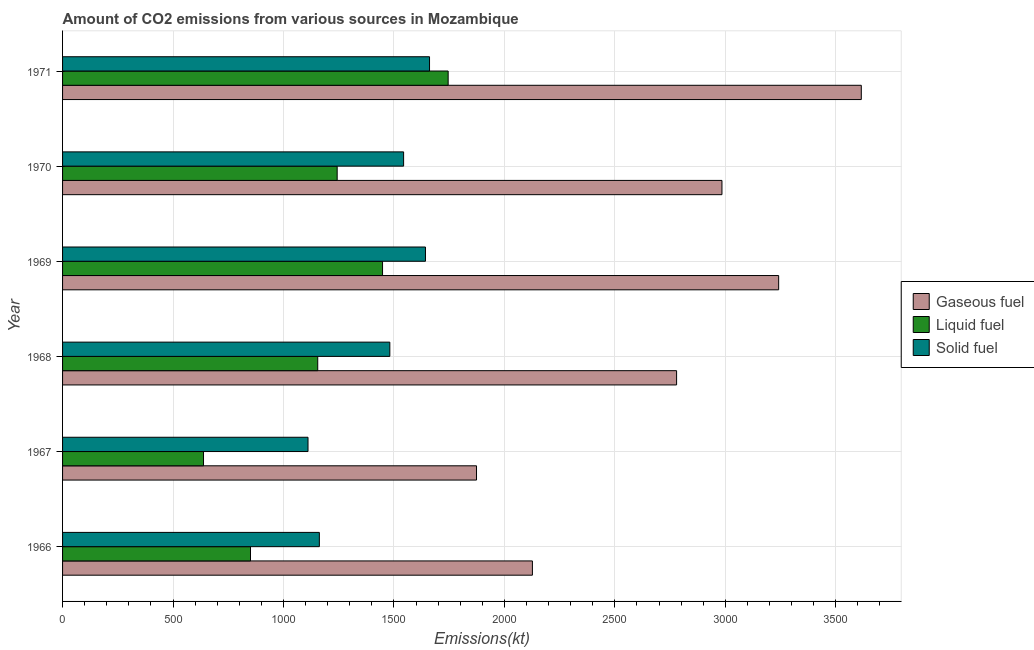How many different coloured bars are there?
Ensure brevity in your answer.  3. How many groups of bars are there?
Provide a succinct answer. 6. How many bars are there on the 5th tick from the top?
Your response must be concise. 3. How many bars are there on the 2nd tick from the bottom?
Your answer should be very brief. 3. What is the label of the 2nd group of bars from the top?
Make the answer very short. 1970. What is the amount of co2 emissions from solid fuel in 1966?
Offer a terse response. 1162.44. Across all years, what is the maximum amount of co2 emissions from gaseous fuel?
Give a very brief answer. 3615.66. Across all years, what is the minimum amount of co2 emissions from solid fuel?
Offer a very short reply. 1111.1. In which year was the amount of co2 emissions from liquid fuel maximum?
Provide a succinct answer. 1971. In which year was the amount of co2 emissions from liquid fuel minimum?
Make the answer very short. 1967. What is the total amount of co2 emissions from liquid fuel in the graph?
Make the answer very short. 7080.98. What is the difference between the amount of co2 emissions from liquid fuel in 1967 and that in 1971?
Offer a terse response. -1107.43. What is the difference between the amount of co2 emissions from liquid fuel in 1968 and the amount of co2 emissions from solid fuel in 1971?
Your answer should be very brief. -506.05. What is the average amount of co2 emissions from solid fuel per year?
Provide a succinct answer. 1433.8. In the year 1967, what is the difference between the amount of co2 emissions from solid fuel and amount of co2 emissions from liquid fuel?
Provide a short and direct response. 473.04. In how many years, is the amount of co2 emissions from liquid fuel greater than 200 kt?
Offer a very short reply. 6. What is the ratio of the amount of co2 emissions from gaseous fuel in 1969 to that in 1971?
Offer a terse response. 0.9. What is the difference between the highest and the second highest amount of co2 emissions from liquid fuel?
Your response must be concise. 297.03. What is the difference between the highest and the lowest amount of co2 emissions from gaseous fuel?
Your answer should be very brief. 1741.82. What does the 3rd bar from the top in 1966 represents?
Keep it short and to the point. Gaseous fuel. What does the 2nd bar from the bottom in 1971 represents?
Your answer should be very brief. Liquid fuel. Are all the bars in the graph horizontal?
Keep it short and to the point. Yes. What is the difference between two consecutive major ticks on the X-axis?
Provide a succinct answer. 500. Are the values on the major ticks of X-axis written in scientific E-notation?
Provide a succinct answer. No. Does the graph contain any zero values?
Your answer should be very brief. No. Does the graph contain grids?
Offer a very short reply. Yes. What is the title of the graph?
Give a very brief answer. Amount of CO2 emissions from various sources in Mozambique. Does "Total employers" appear as one of the legend labels in the graph?
Your answer should be very brief. No. What is the label or title of the X-axis?
Your answer should be very brief. Emissions(kt). What is the Emissions(kt) of Gaseous fuel in 1966?
Provide a succinct answer. 2126.86. What is the Emissions(kt) in Liquid fuel in 1966?
Provide a short and direct response. 850.74. What is the Emissions(kt) in Solid fuel in 1966?
Keep it short and to the point. 1162.44. What is the Emissions(kt) in Gaseous fuel in 1967?
Your response must be concise. 1873.84. What is the Emissions(kt) of Liquid fuel in 1967?
Offer a very short reply. 638.06. What is the Emissions(kt) in Solid fuel in 1967?
Ensure brevity in your answer.  1111.1. What is the Emissions(kt) in Gaseous fuel in 1968?
Your answer should be compact. 2779.59. What is the Emissions(kt) of Liquid fuel in 1968?
Your answer should be very brief. 1155.11. What is the Emissions(kt) of Solid fuel in 1968?
Provide a short and direct response. 1481.47. What is the Emissions(kt) in Gaseous fuel in 1969?
Your answer should be very brief. 3241.63. What is the Emissions(kt) of Liquid fuel in 1969?
Your answer should be very brief. 1448.46. What is the Emissions(kt) of Solid fuel in 1969?
Give a very brief answer. 1642.82. What is the Emissions(kt) of Gaseous fuel in 1970?
Give a very brief answer. 2984.94. What is the Emissions(kt) in Liquid fuel in 1970?
Your response must be concise. 1243.11. What is the Emissions(kt) of Solid fuel in 1970?
Ensure brevity in your answer.  1543.81. What is the Emissions(kt) in Gaseous fuel in 1971?
Your answer should be very brief. 3615.66. What is the Emissions(kt) of Liquid fuel in 1971?
Provide a short and direct response. 1745.49. What is the Emissions(kt) of Solid fuel in 1971?
Provide a short and direct response. 1661.15. Across all years, what is the maximum Emissions(kt) of Gaseous fuel?
Provide a short and direct response. 3615.66. Across all years, what is the maximum Emissions(kt) in Liquid fuel?
Give a very brief answer. 1745.49. Across all years, what is the maximum Emissions(kt) of Solid fuel?
Give a very brief answer. 1661.15. Across all years, what is the minimum Emissions(kt) of Gaseous fuel?
Your answer should be very brief. 1873.84. Across all years, what is the minimum Emissions(kt) of Liquid fuel?
Your answer should be very brief. 638.06. Across all years, what is the minimum Emissions(kt) in Solid fuel?
Make the answer very short. 1111.1. What is the total Emissions(kt) of Gaseous fuel in the graph?
Your answer should be very brief. 1.66e+04. What is the total Emissions(kt) in Liquid fuel in the graph?
Offer a very short reply. 7080.98. What is the total Emissions(kt) in Solid fuel in the graph?
Offer a terse response. 8602.78. What is the difference between the Emissions(kt) in Gaseous fuel in 1966 and that in 1967?
Ensure brevity in your answer.  253.02. What is the difference between the Emissions(kt) in Liquid fuel in 1966 and that in 1967?
Provide a short and direct response. 212.69. What is the difference between the Emissions(kt) of Solid fuel in 1966 and that in 1967?
Your answer should be very brief. 51.34. What is the difference between the Emissions(kt) in Gaseous fuel in 1966 and that in 1968?
Your answer should be compact. -652.73. What is the difference between the Emissions(kt) in Liquid fuel in 1966 and that in 1968?
Offer a terse response. -304.36. What is the difference between the Emissions(kt) in Solid fuel in 1966 and that in 1968?
Make the answer very short. -319.03. What is the difference between the Emissions(kt) of Gaseous fuel in 1966 and that in 1969?
Ensure brevity in your answer.  -1114.77. What is the difference between the Emissions(kt) of Liquid fuel in 1966 and that in 1969?
Your response must be concise. -597.72. What is the difference between the Emissions(kt) in Solid fuel in 1966 and that in 1969?
Your answer should be very brief. -480.38. What is the difference between the Emissions(kt) of Gaseous fuel in 1966 and that in 1970?
Give a very brief answer. -858.08. What is the difference between the Emissions(kt) in Liquid fuel in 1966 and that in 1970?
Make the answer very short. -392.37. What is the difference between the Emissions(kt) of Solid fuel in 1966 and that in 1970?
Give a very brief answer. -381.37. What is the difference between the Emissions(kt) in Gaseous fuel in 1966 and that in 1971?
Your response must be concise. -1488.8. What is the difference between the Emissions(kt) in Liquid fuel in 1966 and that in 1971?
Provide a short and direct response. -894.75. What is the difference between the Emissions(kt) in Solid fuel in 1966 and that in 1971?
Make the answer very short. -498.71. What is the difference between the Emissions(kt) of Gaseous fuel in 1967 and that in 1968?
Ensure brevity in your answer.  -905.75. What is the difference between the Emissions(kt) of Liquid fuel in 1967 and that in 1968?
Offer a terse response. -517.05. What is the difference between the Emissions(kt) of Solid fuel in 1967 and that in 1968?
Offer a very short reply. -370.37. What is the difference between the Emissions(kt) in Gaseous fuel in 1967 and that in 1969?
Your answer should be very brief. -1367.79. What is the difference between the Emissions(kt) in Liquid fuel in 1967 and that in 1969?
Make the answer very short. -810.41. What is the difference between the Emissions(kt) of Solid fuel in 1967 and that in 1969?
Keep it short and to the point. -531.72. What is the difference between the Emissions(kt) of Gaseous fuel in 1967 and that in 1970?
Make the answer very short. -1111.1. What is the difference between the Emissions(kt) in Liquid fuel in 1967 and that in 1970?
Offer a terse response. -605.05. What is the difference between the Emissions(kt) of Solid fuel in 1967 and that in 1970?
Your answer should be very brief. -432.71. What is the difference between the Emissions(kt) in Gaseous fuel in 1967 and that in 1971?
Provide a short and direct response. -1741.83. What is the difference between the Emissions(kt) of Liquid fuel in 1967 and that in 1971?
Give a very brief answer. -1107.43. What is the difference between the Emissions(kt) in Solid fuel in 1967 and that in 1971?
Ensure brevity in your answer.  -550.05. What is the difference between the Emissions(kt) in Gaseous fuel in 1968 and that in 1969?
Your response must be concise. -462.04. What is the difference between the Emissions(kt) in Liquid fuel in 1968 and that in 1969?
Your response must be concise. -293.36. What is the difference between the Emissions(kt) of Solid fuel in 1968 and that in 1969?
Your answer should be very brief. -161.35. What is the difference between the Emissions(kt) in Gaseous fuel in 1968 and that in 1970?
Provide a succinct answer. -205.35. What is the difference between the Emissions(kt) of Liquid fuel in 1968 and that in 1970?
Your answer should be compact. -88.01. What is the difference between the Emissions(kt) of Solid fuel in 1968 and that in 1970?
Keep it short and to the point. -62.34. What is the difference between the Emissions(kt) in Gaseous fuel in 1968 and that in 1971?
Provide a short and direct response. -836.08. What is the difference between the Emissions(kt) of Liquid fuel in 1968 and that in 1971?
Ensure brevity in your answer.  -590.39. What is the difference between the Emissions(kt) of Solid fuel in 1968 and that in 1971?
Offer a very short reply. -179.68. What is the difference between the Emissions(kt) of Gaseous fuel in 1969 and that in 1970?
Your response must be concise. 256.69. What is the difference between the Emissions(kt) in Liquid fuel in 1969 and that in 1970?
Your response must be concise. 205.35. What is the difference between the Emissions(kt) of Solid fuel in 1969 and that in 1970?
Your answer should be compact. 99.01. What is the difference between the Emissions(kt) in Gaseous fuel in 1969 and that in 1971?
Provide a short and direct response. -374.03. What is the difference between the Emissions(kt) in Liquid fuel in 1969 and that in 1971?
Ensure brevity in your answer.  -297.03. What is the difference between the Emissions(kt) of Solid fuel in 1969 and that in 1971?
Give a very brief answer. -18.34. What is the difference between the Emissions(kt) of Gaseous fuel in 1970 and that in 1971?
Offer a terse response. -630.72. What is the difference between the Emissions(kt) of Liquid fuel in 1970 and that in 1971?
Your answer should be very brief. -502.38. What is the difference between the Emissions(kt) in Solid fuel in 1970 and that in 1971?
Give a very brief answer. -117.34. What is the difference between the Emissions(kt) in Gaseous fuel in 1966 and the Emissions(kt) in Liquid fuel in 1967?
Offer a terse response. 1488.8. What is the difference between the Emissions(kt) of Gaseous fuel in 1966 and the Emissions(kt) of Solid fuel in 1967?
Your answer should be compact. 1015.76. What is the difference between the Emissions(kt) in Liquid fuel in 1966 and the Emissions(kt) in Solid fuel in 1967?
Keep it short and to the point. -260.36. What is the difference between the Emissions(kt) in Gaseous fuel in 1966 and the Emissions(kt) in Liquid fuel in 1968?
Offer a terse response. 971.75. What is the difference between the Emissions(kt) of Gaseous fuel in 1966 and the Emissions(kt) of Solid fuel in 1968?
Provide a succinct answer. 645.39. What is the difference between the Emissions(kt) of Liquid fuel in 1966 and the Emissions(kt) of Solid fuel in 1968?
Offer a terse response. -630.72. What is the difference between the Emissions(kt) of Gaseous fuel in 1966 and the Emissions(kt) of Liquid fuel in 1969?
Ensure brevity in your answer.  678.39. What is the difference between the Emissions(kt) in Gaseous fuel in 1966 and the Emissions(kt) in Solid fuel in 1969?
Your answer should be very brief. 484.04. What is the difference between the Emissions(kt) of Liquid fuel in 1966 and the Emissions(kt) of Solid fuel in 1969?
Give a very brief answer. -792.07. What is the difference between the Emissions(kt) in Gaseous fuel in 1966 and the Emissions(kt) in Liquid fuel in 1970?
Provide a succinct answer. 883.75. What is the difference between the Emissions(kt) of Gaseous fuel in 1966 and the Emissions(kt) of Solid fuel in 1970?
Your answer should be very brief. 583.05. What is the difference between the Emissions(kt) of Liquid fuel in 1966 and the Emissions(kt) of Solid fuel in 1970?
Offer a terse response. -693.06. What is the difference between the Emissions(kt) of Gaseous fuel in 1966 and the Emissions(kt) of Liquid fuel in 1971?
Provide a short and direct response. 381.37. What is the difference between the Emissions(kt) in Gaseous fuel in 1966 and the Emissions(kt) in Solid fuel in 1971?
Offer a very short reply. 465.71. What is the difference between the Emissions(kt) in Liquid fuel in 1966 and the Emissions(kt) in Solid fuel in 1971?
Keep it short and to the point. -810.41. What is the difference between the Emissions(kt) of Gaseous fuel in 1967 and the Emissions(kt) of Liquid fuel in 1968?
Give a very brief answer. 718.73. What is the difference between the Emissions(kt) in Gaseous fuel in 1967 and the Emissions(kt) in Solid fuel in 1968?
Provide a short and direct response. 392.37. What is the difference between the Emissions(kt) of Liquid fuel in 1967 and the Emissions(kt) of Solid fuel in 1968?
Provide a short and direct response. -843.41. What is the difference between the Emissions(kt) of Gaseous fuel in 1967 and the Emissions(kt) of Liquid fuel in 1969?
Offer a terse response. 425.37. What is the difference between the Emissions(kt) in Gaseous fuel in 1967 and the Emissions(kt) in Solid fuel in 1969?
Ensure brevity in your answer.  231.02. What is the difference between the Emissions(kt) of Liquid fuel in 1967 and the Emissions(kt) of Solid fuel in 1969?
Provide a short and direct response. -1004.76. What is the difference between the Emissions(kt) of Gaseous fuel in 1967 and the Emissions(kt) of Liquid fuel in 1970?
Ensure brevity in your answer.  630.72. What is the difference between the Emissions(kt) of Gaseous fuel in 1967 and the Emissions(kt) of Solid fuel in 1970?
Make the answer very short. 330.03. What is the difference between the Emissions(kt) of Liquid fuel in 1967 and the Emissions(kt) of Solid fuel in 1970?
Your answer should be very brief. -905.75. What is the difference between the Emissions(kt) of Gaseous fuel in 1967 and the Emissions(kt) of Liquid fuel in 1971?
Keep it short and to the point. 128.34. What is the difference between the Emissions(kt) of Gaseous fuel in 1967 and the Emissions(kt) of Solid fuel in 1971?
Your response must be concise. 212.69. What is the difference between the Emissions(kt) of Liquid fuel in 1967 and the Emissions(kt) of Solid fuel in 1971?
Ensure brevity in your answer.  -1023.09. What is the difference between the Emissions(kt) of Gaseous fuel in 1968 and the Emissions(kt) of Liquid fuel in 1969?
Your answer should be very brief. 1331.12. What is the difference between the Emissions(kt) in Gaseous fuel in 1968 and the Emissions(kt) in Solid fuel in 1969?
Offer a very short reply. 1136.77. What is the difference between the Emissions(kt) in Liquid fuel in 1968 and the Emissions(kt) in Solid fuel in 1969?
Your answer should be compact. -487.71. What is the difference between the Emissions(kt) of Gaseous fuel in 1968 and the Emissions(kt) of Liquid fuel in 1970?
Your answer should be very brief. 1536.47. What is the difference between the Emissions(kt) of Gaseous fuel in 1968 and the Emissions(kt) of Solid fuel in 1970?
Offer a terse response. 1235.78. What is the difference between the Emissions(kt) in Liquid fuel in 1968 and the Emissions(kt) in Solid fuel in 1970?
Provide a succinct answer. -388.7. What is the difference between the Emissions(kt) in Gaseous fuel in 1968 and the Emissions(kt) in Liquid fuel in 1971?
Ensure brevity in your answer.  1034.09. What is the difference between the Emissions(kt) of Gaseous fuel in 1968 and the Emissions(kt) of Solid fuel in 1971?
Offer a terse response. 1118.43. What is the difference between the Emissions(kt) of Liquid fuel in 1968 and the Emissions(kt) of Solid fuel in 1971?
Offer a very short reply. -506.05. What is the difference between the Emissions(kt) in Gaseous fuel in 1969 and the Emissions(kt) in Liquid fuel in 1970?
Your answer should be very brief. 1998.52. What is the difference between the Emissions(kt) in Gaseous fuel in 1969 and the Emissions(kt) in Solid fuel in 1970?
Your answer should be compact. 1697.82. What is the difference between the Emissions(kt) of Liquid fuel in 1969 and the Emissions(kt) of Solid fuel in 1970?
Offer a terse response. -95.34. What is the difference between the Emissions(kt) in Gaseous fuel in 1969 and the Emissions(kt) in Liquid fuel in 1971?
Your response must be concise. 1496.14. What is the difference between the Emissions(kt) of Gaseous fuel in 1969 and the Emissions(kt) of Solid fuel in 1971?
Give a very brief answer. 1580.48. What is the difference between the Emissions(kt) of Liquid fuel in 1969 and the Emissions(kt) of Solid fuel in 1971?
Your answer should be very brief. -212.69. What is the difference between the Emissions(kt) of Gaseous fuel in 1970 and the Emissions(kt) of Liquid fuel in 1971?
Provide a succinct answer. 1239.45. What is the difference between the Emissions(kt) in Gaseous fuel in 1970 and the Emissions(kt) in Solid fuel in 1971?
Your answer should be compact. 1323.79. What is the difference between the Emissions(kt) of Liquid fuel in 1970 and the Emissions(kt) of Solid fuel in 1971?
Ensure brevity in your answer.  -418.04. What is the average Emissions(kt) of Gaseous fuel per year?
Ensure brevity in your answer.  2770.42. What is the average Emissions(kt) of Liquid fuel per year?
Offer a terse response. 1180.16. What is the average Emissions(kt) in Solid fuel per year?
Your answer should be compact. 1433.8. In the year 1966, what is the difference between the Emissions(kt) in Gaseous fuel and Emissions(kt) in Liquid fuel?
Provide a short and direct response. 1276.12. In the year 1966, what is the difference between the Emissions(kt) of Gaseous fuel and Emissions(kt) of Solid fuel?
Make the answer very short. 964.42. In the year 1966, what is the difference between the Emissions(kt) in Liquid fuel and Emissions(kt) in Solid fuel?
Your answer should be compact. -311.69. In the year 1967, what is the difference between the Emissions(kt) of Gaseous fuel and Emissions(kt) of Liquid fuel?
Your answer should be very brief. 1235.78. In the year 1967, what is the difference between the Emissions(kt) of Gaseous fuel and Emissions(kt) of Solid fuel?
Make the answer very short. 762.74. In the year 1967, what is the difference between the Emissions(kt) of Liquid fuel and Emissions(kt) of Solid fuel?
Provide a short and direct response. -473.04. In the year 1968, what is the difference between the Emissions(kt) of Gaseous fuel and Emissions(kt) of Liquid fuel?
Offer a terse response. 1624.48. In the year 1968, what is the difference between the Emissions(kt) in Gaseous fuel and Emissions(kt) in Solid fuel?
Offer a very short reply. 1298.12. In the year 1968, what is the difference between the Emissions(kt) of Liquid fuel and Emissions(kt) of Solid fuel?
Offer a very short reply. -326.36. In the year 1969, what is the difference between the Emissions(kt) in Gaseous fuel and Emissions(kt) in Liquid fuel?
Your response must be concise. 1793.16. In the year 1969, what is the difference between the Emissions(kt) in Gaseous fuel and Emissions(kt) in Solid fuel?
Offer a terse response. 1598.81. In the year 1969, what is the difference between the Emissions(kt) of Liquid fuel and Emissions(kt) of Solid fuel?
Provide a short and direct response. -194.35. In the year 1970, what is the difference between the Emissions(kt) of Gaseous fuel and Emissions(kt) of Liquid fuel?
Your response must be concise. 1741.83. In the year 1970, what is the difference between the Emissions(kt) in Gaseous fuel and Emissions(kt) in Solid fuel?
Your answer should be very brief. 1441.13. In the year 1970, what is the difference between the Emissions(kt) in Liquid fuel and Emissions(kt) in Solid fuel?
Give a very brief answer. -300.69. In the year 1971, what is the difference between the Emissions(kt) of Gaseous fuel and Emissions(kt) of Liquid fuel?
Give a very brief answer. 1870.17. In the year 1971, what is the difference between the Emissions(kt) in Gaseous fuel and Emissions(kt) in Solid fuel?
Provide a succinct answer. 1954.51. In the year 1971, what is the difference between the Emissions(kt) in Liquid fuel and Emissions(kt) in Solid fuel?
Ensure brevity in your answer.  84.34. What is the ratio of the Emissions(kt) of Gaseous fuel in 1966 to that in 1967?
Offer a very short reply. 1.14. What is the ratio of the Emissions(kt) of Liquid fuel in 1966 to that in 1967?
Offer a very short reply. 1.33. What is the ratio of the Emissions(kt) of Solid fuel in 1966 to that in 1967?
Ensure brevity in your answer.  1.05. What is the ratio of the Emissions(kt) in Gaseous fuel in 1966 to that in 1968?
Provide a succinct answer. 0.77. What is the ratio of the Emissions(kt) in Liquid fuel in 1966 to that in 1968?
Ensure brevity in your answer.  0.74. What is the ratio of the Emissions(kt) in Solid fuel in 1966 to that in 1968?
Provide a short and direct response. 0.78. What is the ratio of the Emissions(kt) of Gaseous fuel in 1966 to that in 1969?
Provide a short and direct response. 0.66. What is the ratio of the Emissions(kt) in Liquid fuel in 1966 to that in 1969?
Keep it short and to the point. 0.59. What is the ratio of the Emissions(kt) of Solid fuel in 1966 to that in 1969?
Provide a succinct answer. 0.71. What is the ratio of the Emissions(kt) of Gaseous fuel in 1966 to that in 1970?
Your answer should be very brief. 0.71. What is the ratio of the Emissions(kt) in Liquid fuel in 1966 to that in 1970?
Keep it short and to the point. 0.68. What is the ratio of the Emissions(kt) in Solid fuel in 1966 to that in 1970?
Keep it short and to the point. 0.75. What is the ratio of the Emissions(kt) in Gaseous fuel in 1966 to that in 1971?
Your response must be concise. 0.59. What is the ratio of the Emissions(kt) of Liquid fuel in 1966 to that in 1971?
Ensure brevity in your answer.  0.49. What is the ratio of the Emissions(kt) of Solid fuel in 1966 to that in 1971?
Offer a very short reply. 0.7. What is the ratio of the Emissions(kt) of Gaseous fuel in 1967 to that in 1968?
Provide a succinct answer. 0.67. What is the ratio of the Emissions(kt) of Liquid fuel in 1967 to that in 1968?
Your response must be concise. 0.55. What is the ratio of the Emissions(kt) in Solid fuel in 1967 to that in 1968?
Make the answer very short. 0.75. What is the ratio of the Emissions(kt) of Gaseous fuel in 1967 to that in 1969?
Your answer should be compact. 0.58. What is the ratio of the Emissions(kt) in Liquid fuel in 1967 to that in 1969?
Keep it short and to the point. 0.44. What is the ratio of the Emissions(kt) in Solid fuel in 1967 to that in 1969?
Provide a succinct answer. 0.68. What is the ratio of the Emissions(kt) in Gaseous fuel in 1967 to that in 1970?
Your answer should be very brief. 0.63. What is the ratio of the Emissions(kt) in Liquid fuel in 1967 to that in 1970?
Offer a terse response. 0.51. What is the ratio of the Emissions(kt) in Solid fuel in 1967 to that in 1970?
Offer a very short reply. 0.72. What is the ratio of the Emissions(kt) in Gaseous fuel in 1967 to that in 1971?
Ensure brevity in your answer.  0.52. What is the ratio of the Emissions(kt) in Liquid fuel in 1967 to that in 1971?
Provide a short and direct response. 0.37. What is the ratio of the Emissions(kt) of Solid fuel in 1967 to that in 1971?
Keep it short and to the point. 0.67. What is the ratio of the Emissions(kt) in Gaseous fuel in 1968 to that in 1969?
Your answer should be compact. 0.86. What is the ratio of the Emissions(kt) of Liquid fuel in 1968 to that in 1969?
Give a very brief answer. 0.8. What is the ratio of the Emissions(kt) of Solid fuel in 1968 to that in 1969?
Ensure brevity in your answer.  0.9. What is the ratio of the Emissions(kt) of Gaseous fuel in 1968 to that in 1970?
Make the answer very short. 0.93. What is the ratio of the Emissions(kt) of Liquid fuel in 1968 to that in 1970?
Provide a succinct answer. 0.93. What is the ratio of the Emissions(kt) in Solid fuel in 1968 to that in 1970?
Provide a succinct answer. 0.96. What is the ratio of the Emissions(kt) in Gaseous fuel in 1968 to that in 1971?
Your response must be concise. 0.77. What is the ratio of the Emissions(kt) of Liquid fuel in 1968 to that in 1971?
Provide a short and direct response. 0.66. What is the ratio of the Emissions(kt) in Solid fuel in 1968 to that in 1971?
Your response must be concise. 0.89. What is the ratio of the Emissions(kt) in Gaseous fuel in 1969 to that in 1970?
Your answer should be very brief. 1.09. What is the ratio of the Emissions(kt) in Liquid fuel in 1969 to that in 1970?
Offer a terse response. 1.17. What is the ratio of the Emissions(kt) of Solid fuel in 1969 to that in 1970?
Provide a succinct answer. 1.06. What is the ratio of the Emissions(kt) in Gaseous fuel in 1969 to that in 1971?
Your answer should be very brief. 0.9. What is the ratio of the Emissions(kt) in Liquid fuel in 1969 to that in 1971?
Make the answer very short. 0.83. What is the ratio of the Emissions(kt) of Solid fuel in 1969 to that in 1971?
Offer a terse response. 0.99. What is the ratio of the Emissions(kt) in Gaseous fuel in 1970 to that in 1971?
Provide a short and direct response. 0.83. What is the ratio of the Emissions(kt) of Liquid fuel in 1970 to that in 1971?
Your answer should be very brief. 0.71. What is the ratio of the Emissions(kt) in Solid fuel in 1970 to that in 1971?
Your response must be concise. 0.93. What is the difference between the highest and the second highest Emissions(kt) of Gaseous fuel?
Your answer should be very brief. 374.03. What is the difference between the highest and the second highest Emissions(kt) of Liquid fuel?
Provide a short and direct response. 297.03. What is the difference between the highest and the second highest Emissions(kt) in Solid fuel?
Ensure brevity in your answer.  18.34. What is the difference between the highest and the lowest Emissions(kt) of Gaseous fuel?
Keep it short and to the point. 1741.83. What is the difference between the highest and the lowest Emissions(kt) in Liquid fuel?
Make the answer very short. 1107.43. What is the difference between the highest and the lowest Emissions(kt) of Solid fuel?
Offer a very short reply. 550.05. 